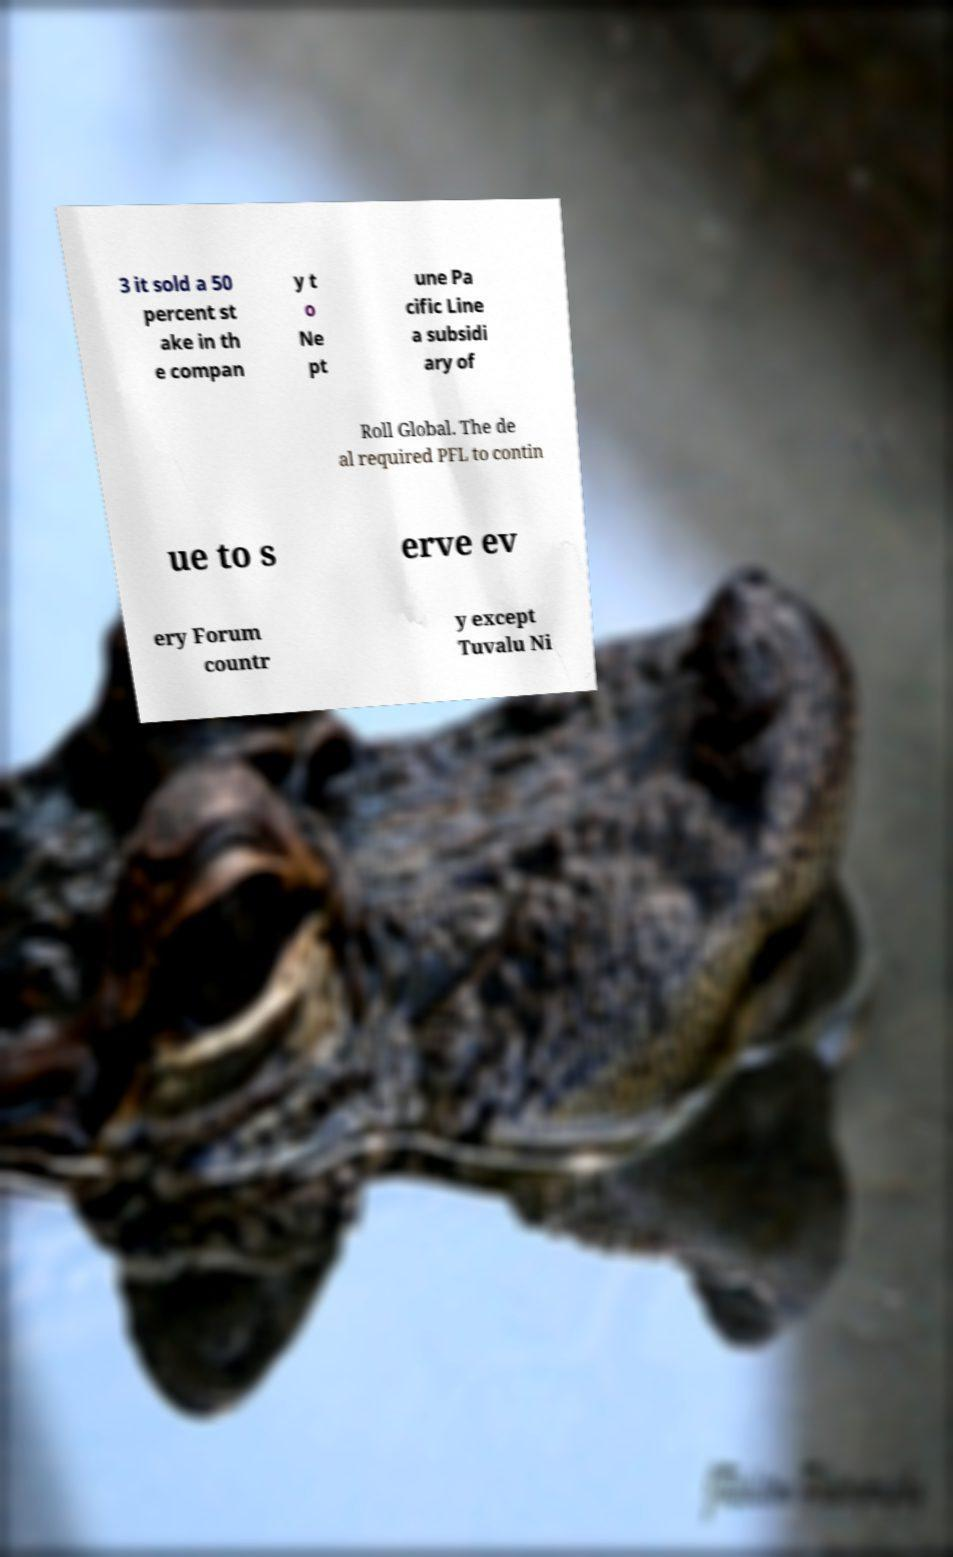Please identify and transcribe the text found in this image. 3 it sold a 50 percent st ake in th e compan y t o Ne pt une Pa cific Line a subsidi ary of Roll Global. The de al required PFL to contin ue to s erve ev ery Forum countr y except Tuvalu Ni 